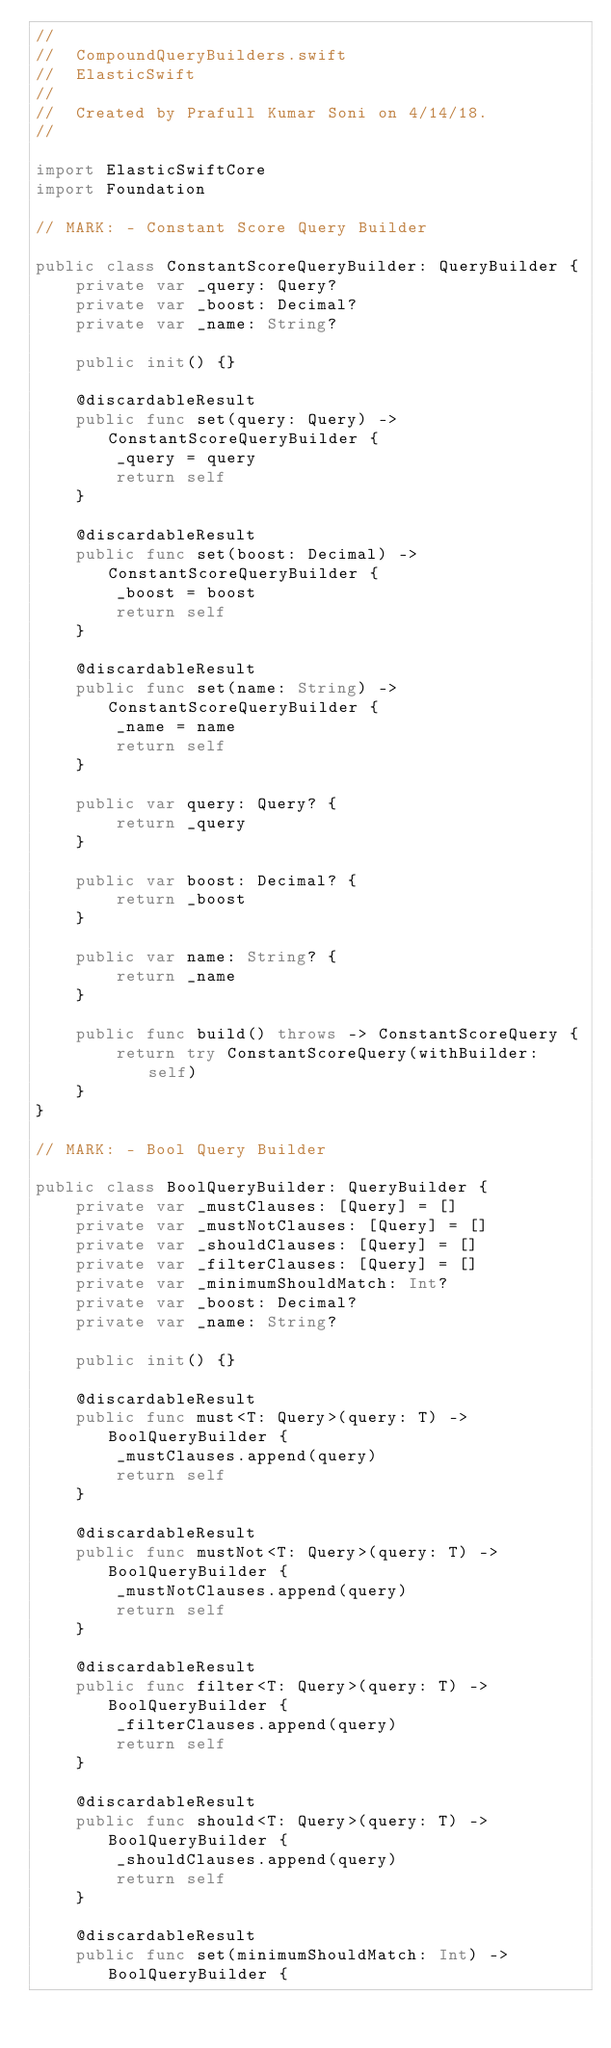<code> <loc_0><loc_0><loc_500><loc_500><_Swift_>//
//  CompoundQueryBuilders.swift
//  ElasticSwift
//
//  Created by Prafull Kumar Soni on 4/14/18.
//

import ElasticSwiftCore
import Foundation

// MARK: - Constant Score Query Builder

public class ConstantScoreQueryBuilder: QueryBuilder {
    private var _query: Query?
    private var _boost: Decimal?
    private var _name: String?

    public init() {}

    @discardableResult
    public func set(query: Query) -> ConstantScoreQueryBuilder {
        _query = query
        return self
    }

    @discardableResult
    public func set(boost: Decimal) -> ConstantScoreQueryBuilder {
        _boost = boost
        return self
    }

    @discardableResult
    public func set(name: String) -> ConstantScoreQueryBuilder {
        _name = name
        return self
    }

    public var query: Query? {
        return _query
    }

    public var boost: Decimal? {
        return _boost
    }

    public var name: String? {
        return _name
    }

    public func build() throws -> ConstantScoreQuery {
        return try ConstantScoreQuery(withBuilder: self)
    }
}

// MARK: - Bool Query Builder

public class BoolQueryBuilder: QueryBuilder {
    private var _mustClauses: [Query] = []
    private var _mustNotClauses: [Query] = []
    private var _shouldClauses: [Query] = []
    private var _filterClauses: [Query] = []
    private var _minimumShouldMatch: Int?
    private var _boost: Decimal?
    private var _name: String?

    public init() {}

    @discardableResult
    public func must<T: Query>(query: T) -> BoolQueryBuilder {
        _mustClauses.append(query)
        return self
    }

    @discardableResult
    public func mustNot<T: Query>(query: T) -> BoolQueryBuilder {
        _mustNotClauses.append(query)
        return self
    }

    @discardableResult
    public func filter<T: Query>(query: T) -> BoolQueryBuilder {
        _filterClauses.append(query)
        return self
    }

    @discardableResult
    public func should<T: Query>(query: T) -> BoolQueryBuilder {
        _shouldClauses.append(query)
        return self
    }

    @discardableResult
    public func set(minimumShouldMatch: Int) -> BoolQueryBuilder {</code> 